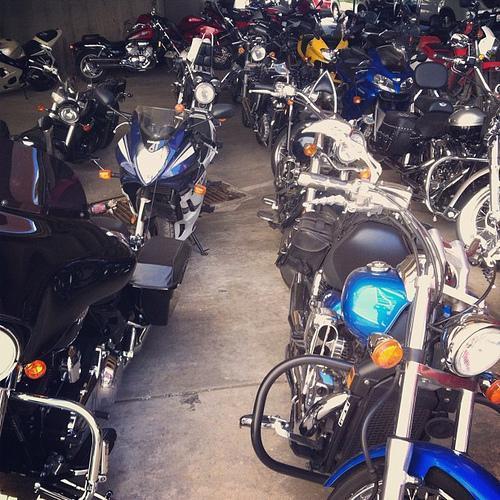How many headlights does the front right motorcycle have?
Give a very brief answer. 1. 